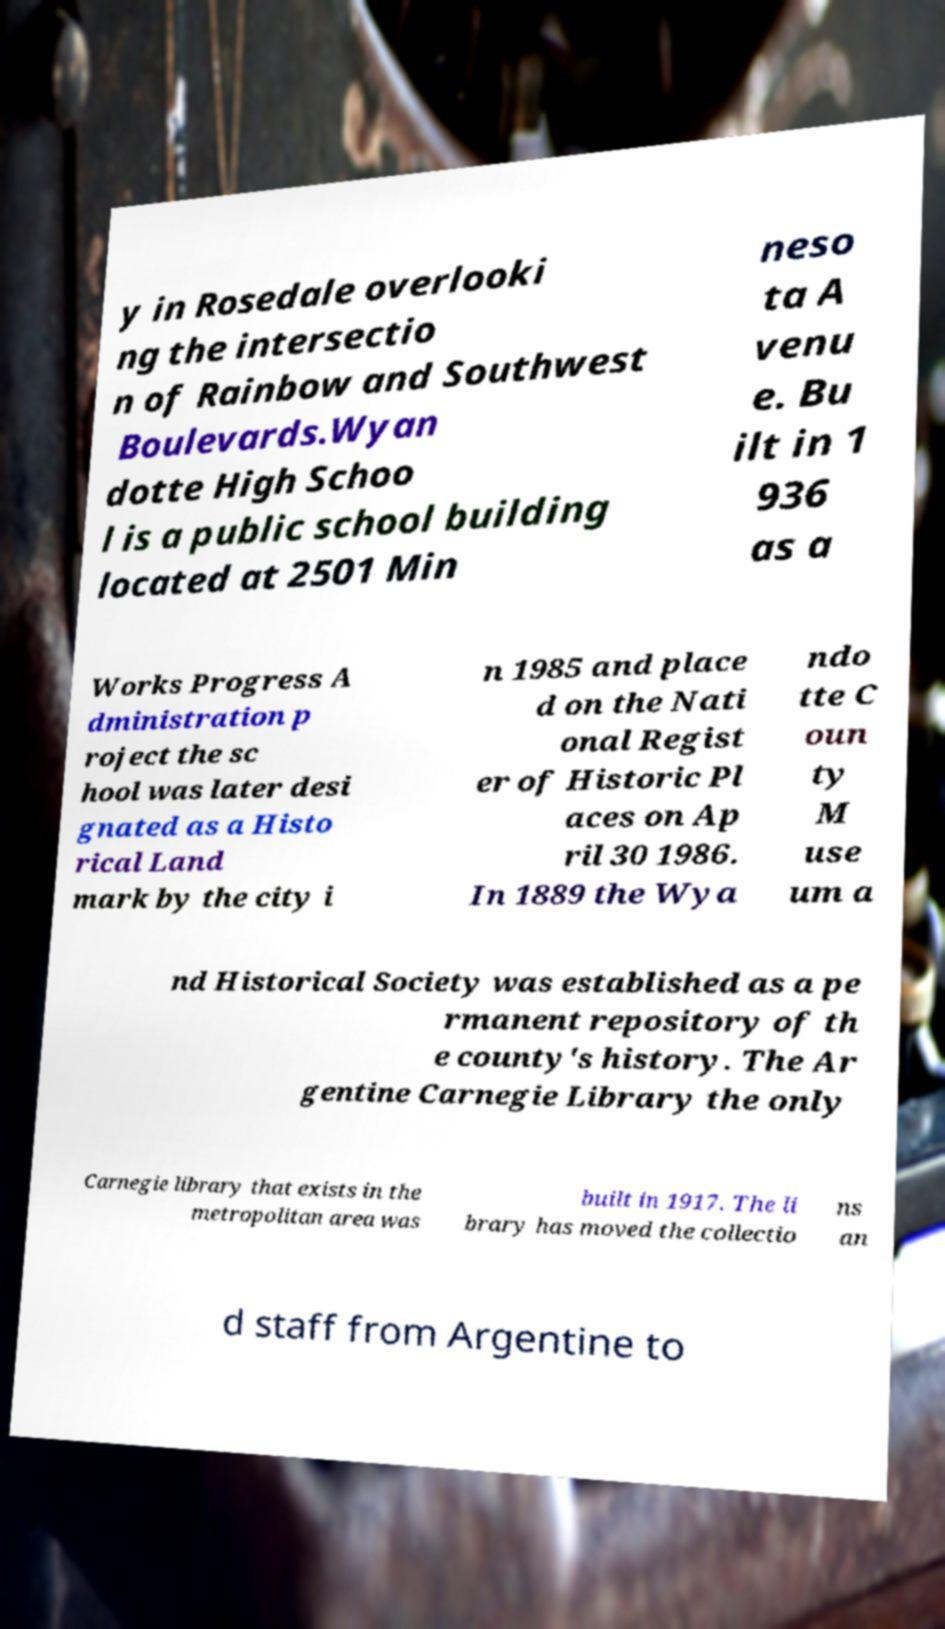I need the written content from this picture converted into text. Can you do that? y in Rosedale overlooki ng the intersectio n of Rainbow and Southwest Boulevards.Wyan dotte High Schoo l is a public school building located at 2501 Min neso ta A venu e. Bu ilt in 1 936 as a Works Progress A dministration p roject the sc hool was later desi gnated as a Histo rical Land mark by the city i n 1985 and place d on the Nati onal Regist er of Historic Pl aces on Ap ril 30 1986. In 1889 the Wya ndo tte C oun ty M use um a nd Historical Society was established as a pe rmanent repository of th e county's history. The Ar gentine Carnegie Library the only Carnegie library that exists in the metropolitan area was built in 1917. The li brary has moved the collectio ns an d staff from Argentine to 